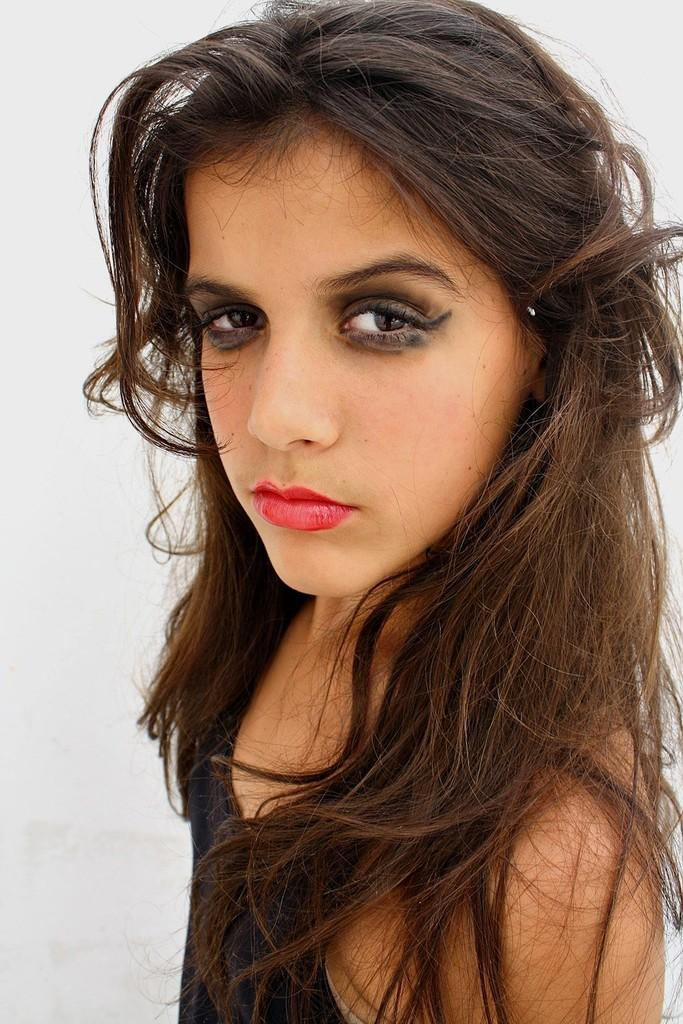Who is the main subject in the image? There is a girl in the middle of the image. What color is the background of the image? The background of the image is white in color. What type of protest is the girl participating in the image? There is no protest present in the image; it only features a girl in the middle of a white background. 